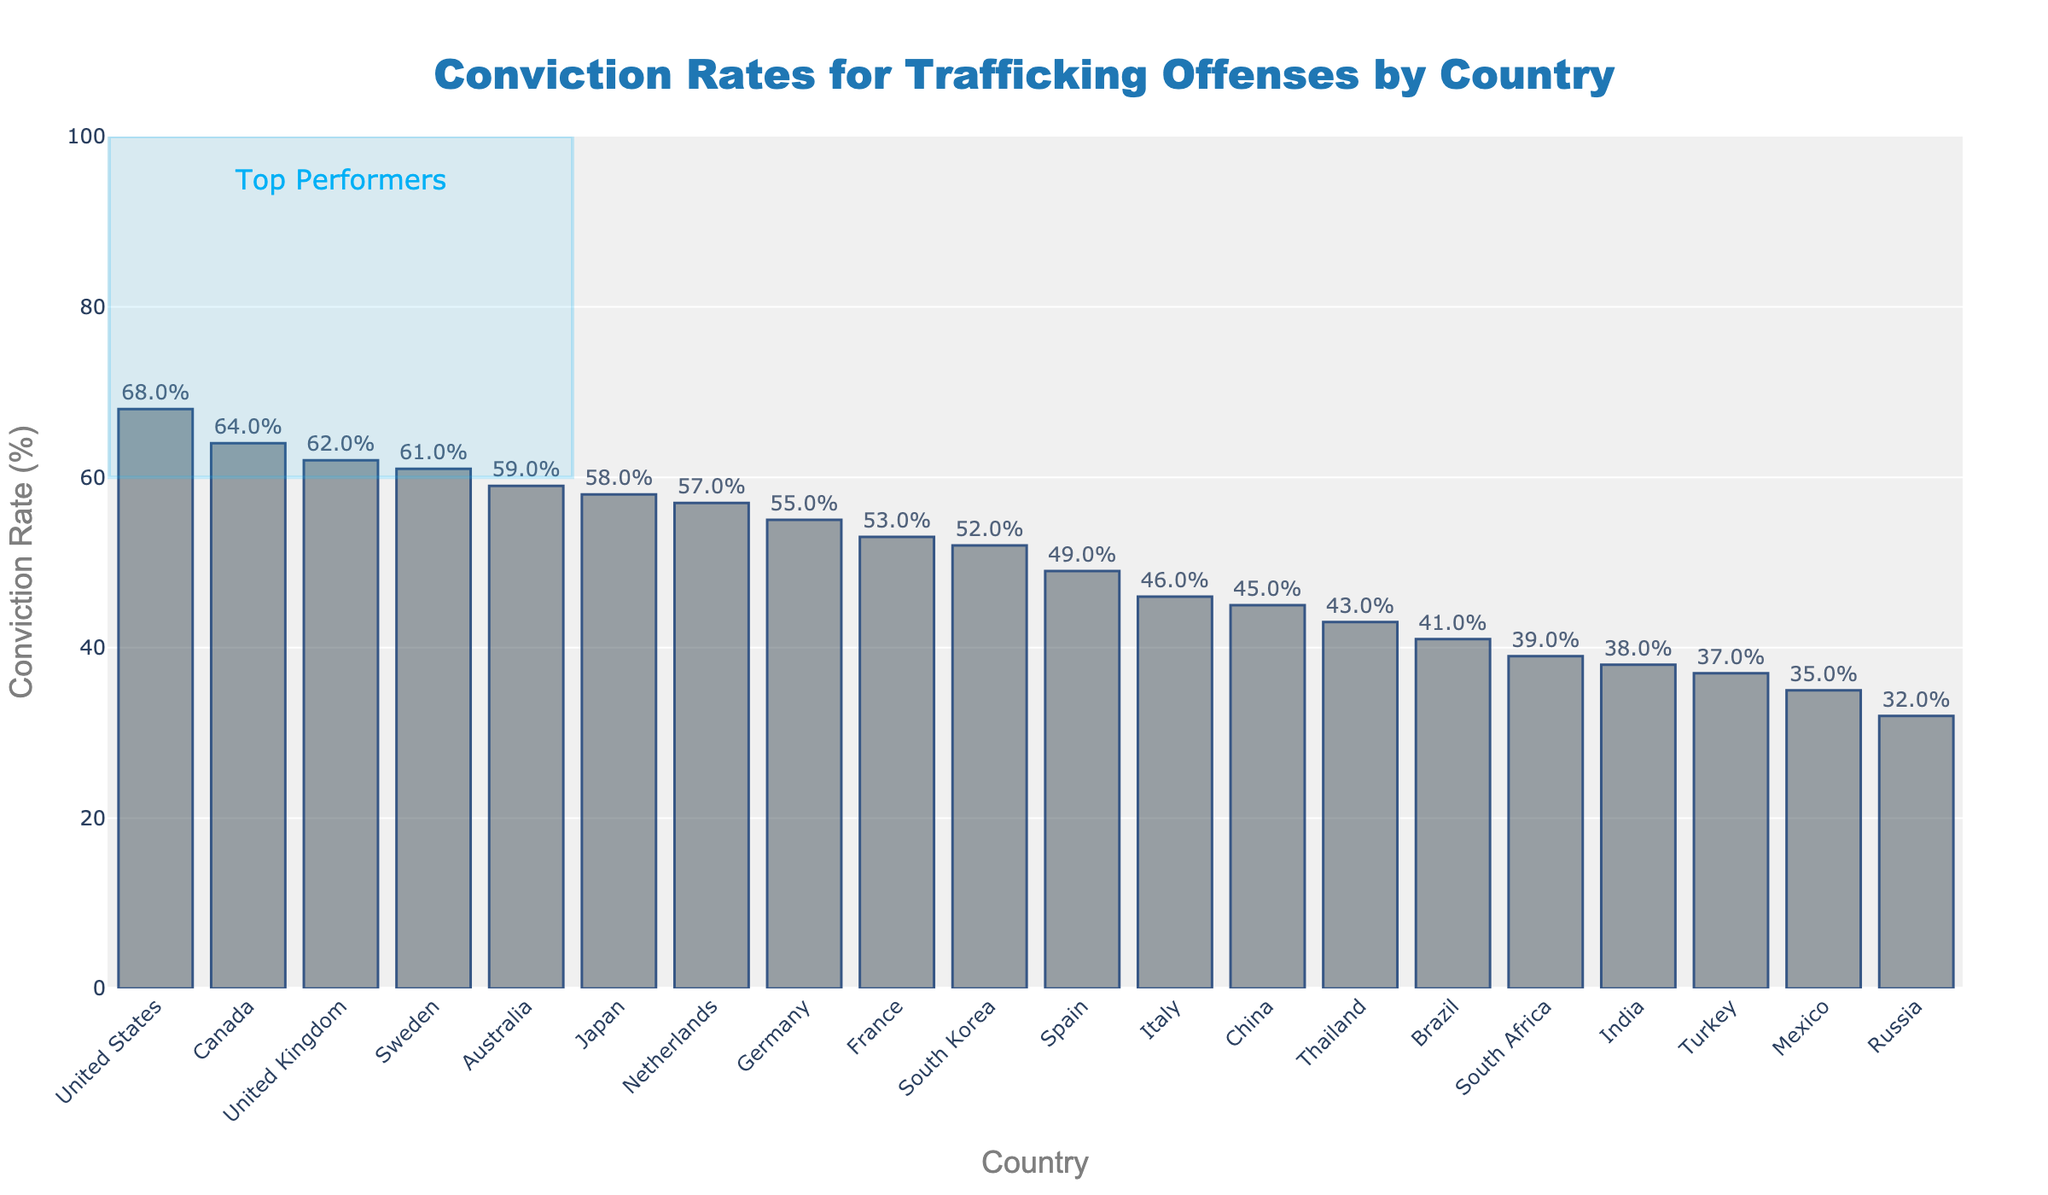Which country has the highest conviction rate for trafficking offenses? The highest bar represents the country with the highest conviction rate. Referring to the figure, the United States has the tallest bar.
Answer: United States Which country has the lowest conviction rate for trafficking offenses? The shortest bar represents the country with the lowest conviction rate. Referring to the figure, Russia has the shortest bar.
Answer: Russia What is the difference in conviction rates between the United States and Mexico? The conviction rate for the United States is 68%, and for Mexico, it is 35%. Subtracting these gives: 68% - 35% = 33%.
Answer: 33% Which countries have conviction rates higher than 60%? The countries with bars extending beyond the 60% mark are the United States, United Kingdom, Canada, and Sweden.
Answer: United States, United Kingdom, Canada, Sweden What is the average conviction rate of the top five countries? The top five countries by conviction rates are: United States (68%), Canada (64%), United Kingdom (62%), Sweden (61%), and Australia (59%). Adding these gives: 68 + 64 + 62 + 61 + 59 = 314. Dividing by 5 gives: 314 / 5 = 62.8%.
Answer: 62.8% What are the conviction rates of the countries highlighted as "Top Performers"? The countries highlighted are the United States, Canada, United Kingdom, and Sweden. Their conviction rates are as follows: United States (68%), Canada (64%), United Kingdom (62%), and Sweden (61%).
Answer: United States: 68%, Canada: 64%, United Kingdom: 62%, Sweden: 61% How many countries have conviction rates less than 50%? Count the countries represented by bars that do not reach the 50% mark. The countries are Spain, Italy, Thailand, India, Brazil, Mexico, South Africa, Russia, China, and Turkey.
Answer: 10 What is the median conviction rate among all listed countries? To find the median, list all conviction rates in ascending order: 32, 35, 37, 38, 39, 41, 43, 45, 46, 49, 52, 53, 55, 57, 58, 59, 61, 62, 64, 68. The median is the middle value, which is the average of the 10th and 11th values (49 + 52) / 2 = 50.5%.
Answer: 50.5% What is the range of conviction rates shown in the figure? To find the range, subtract the lowest conviction rate from the highest. The highest rate is 68%, and the lowest is 32%. Therefore, the range is 68% - 32% = 36%.
Answer: 36% Which country has a conviction rate closest to 50%? Locate the bar closest to the 50% mark. South Korea, with a conviction rate of 52%, is closest to 50%.
Answer: South Korea 